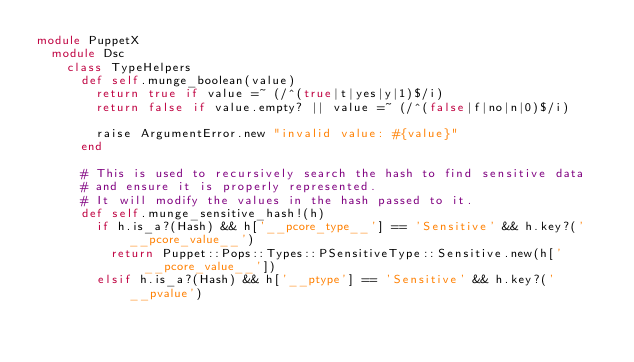<code> <loc_0><loc_0><loc_500><loc_500><_Ruby_>module PuppetX
  module Dsc
    class TypeHelpers
      def self.munge_boolean(value)
        return true if value =~ (/^(true|t|yes|y|1)$/i)
        return false if value.empty? || value =~ (/^(false|f|no|n|0)$/i)

        raise ArgumentError.new "invalid value: #{value}"
      end

      # This is used to recursively search the hash to find sensitive data
      # and ensure it is properly represented.
      # It will modify the values in the hash passed to it.
      def self.munge_sensitive_hash!(h)
        if h.is_a?(Hash) && h['__pcore_type__'] == 'Sensitive' && h.key?('__pcore_value__')
          return Puppet::Pops::Types::PSensitiveType::Sensitive.new(h['__pcore_value__'])
        elsif h.is_a?(Hash) && h['__ptype'] == 'Sensitive' && h.key?('__pvalue')</code> 